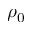Convert formula to latex. <formula><loc_0><loc_0><loc_500><loc_500>\rho _ { 0 }</formula> 